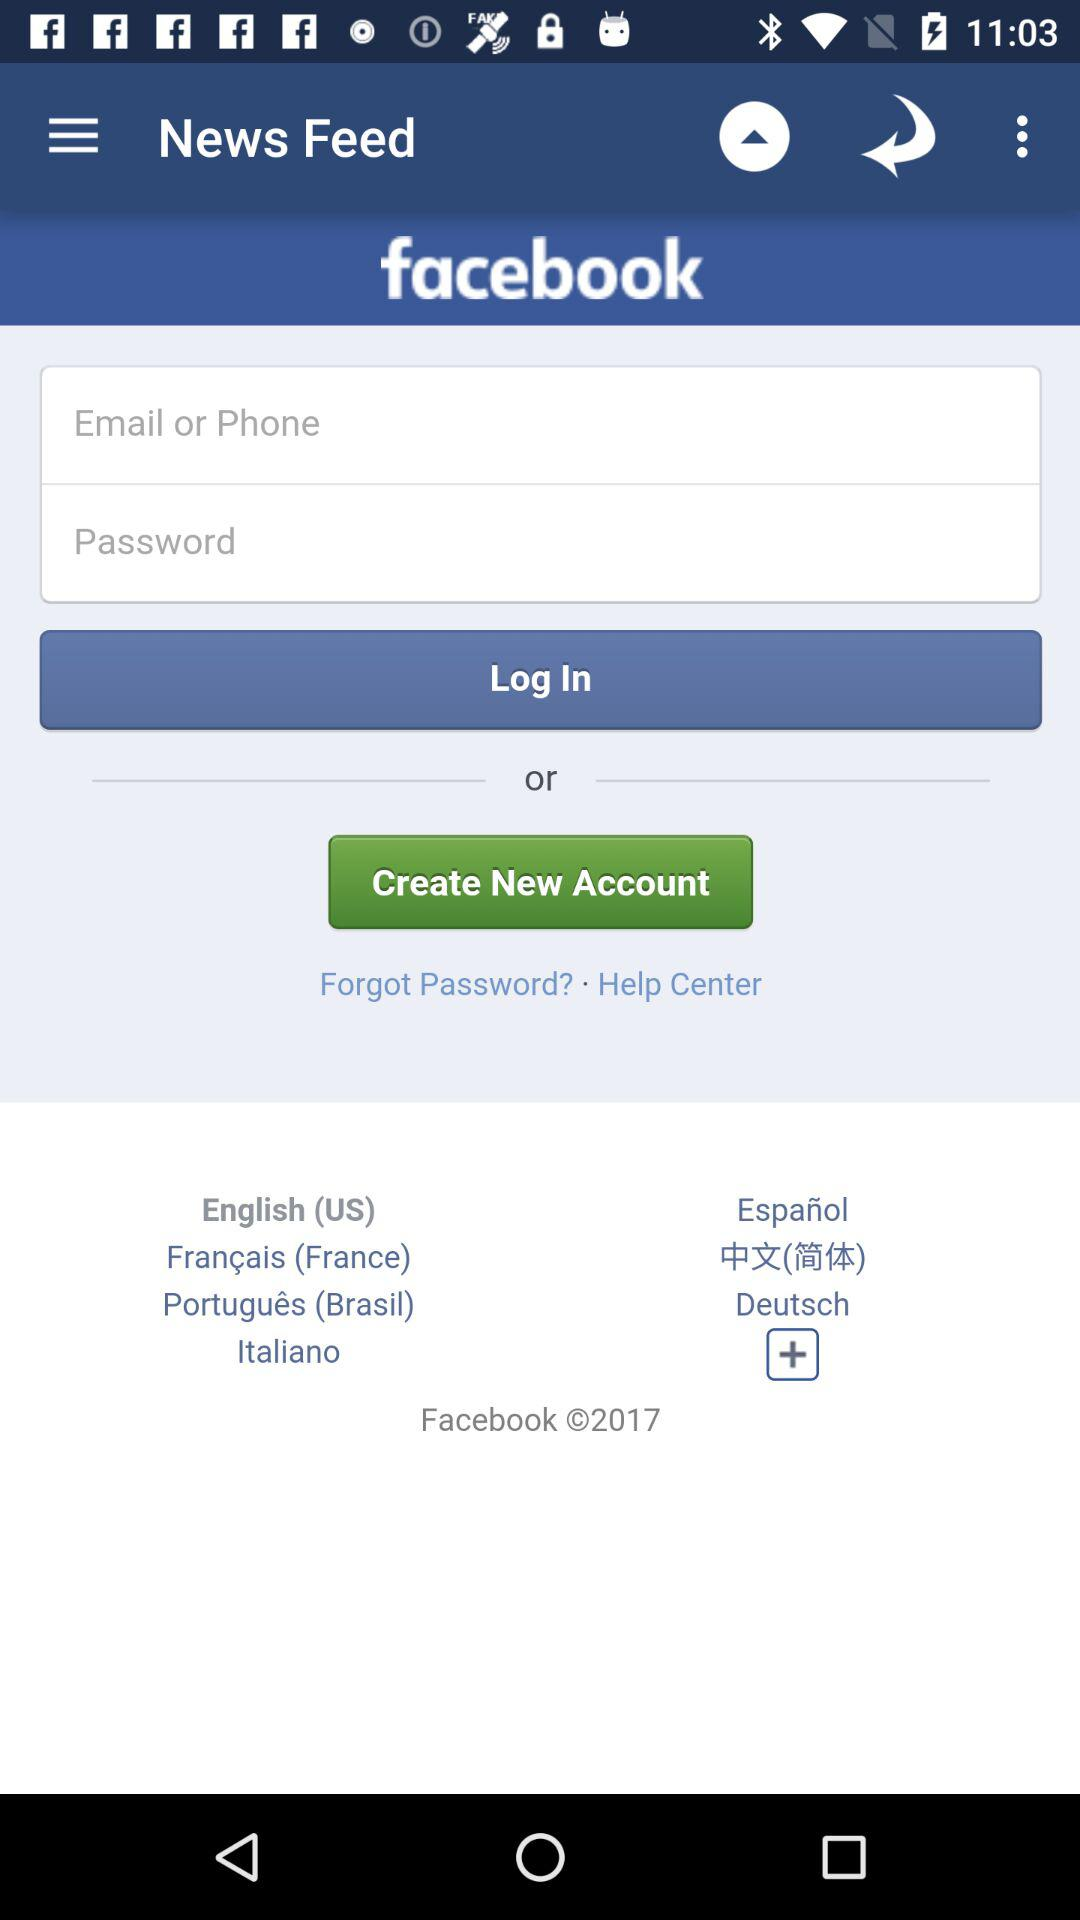How many languages are available for selection on this page?
Answer the question using a single word or phrase. 7 